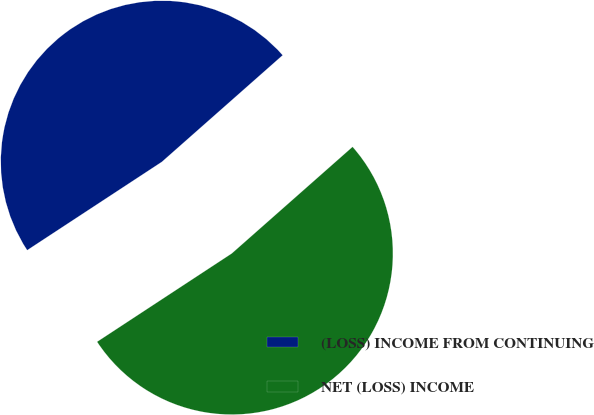<chart> <loc_0><loc_0><loc_500><loc_500><pie_chart><fcel>(LOSS) INCOME FROM CONTINUING<fcel>NET (LOSS) INCOME<nl><fcel>47.73%<fcel>52.27%<nl></chart> 